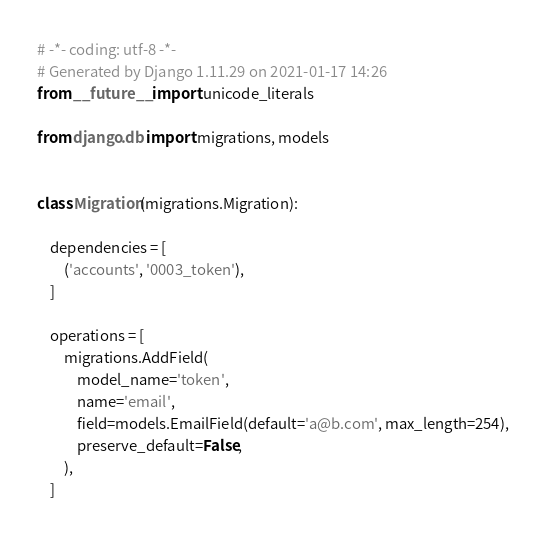Convert code to text. <code><loc_0><loc_0><loc_500><loc_500><_Python_># -*- coding: utf-8 -*-
# Generated by Django 1.11.29 on 2021-01-17 14:26
from __future__ import unicode_literals

from django.db import migrations, models


class Migration(migrations.Migration):

    dependencies = [
        ('accounts', '0003_token'),
    ]

    operations = [
        migrations.AddField(
            model_name='token',
            name='email',
            field=models.EmailField(default='a@b.com', max_length=254),
            preserve_default=False,
        ),
    ]
</code> 